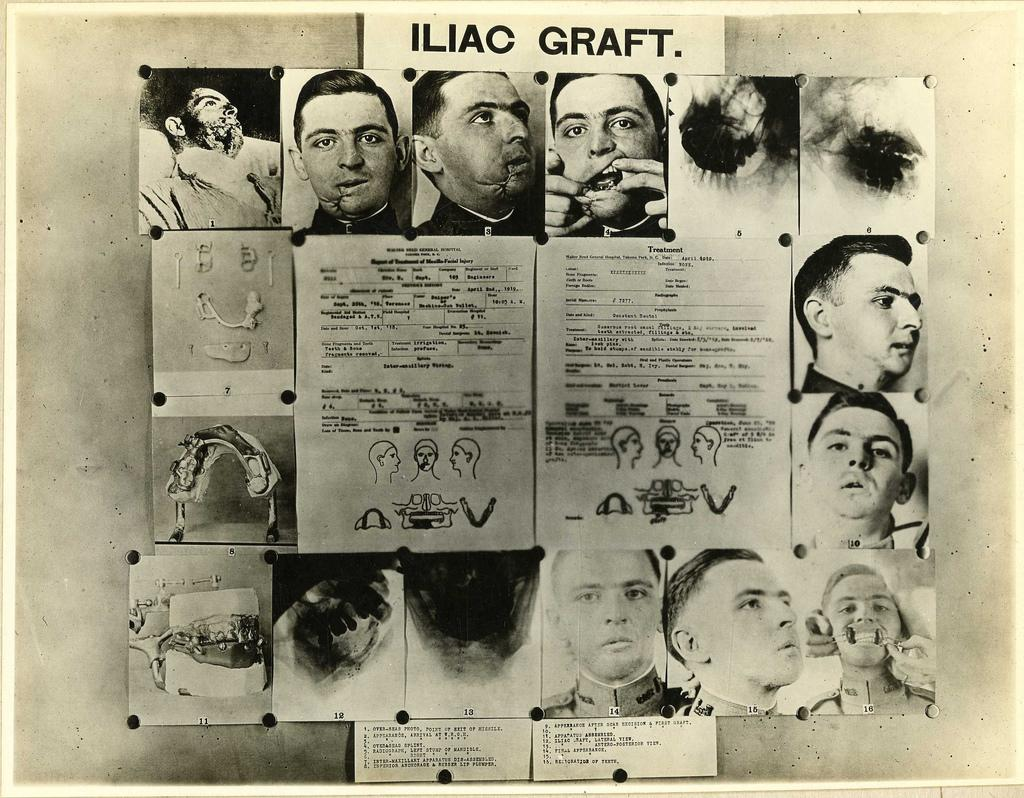What is the main subject of the image? The main subject of the image is many pictures of persons. Where are these pictures located in the image? These pictures are located at the center of the image. What type of bells can be heard ringing in the image? There are no bells present in the image, and therefore no sound can be heard. What news is being reported in the image? There is no news being reported in the image; it only contains pictures of persons. 